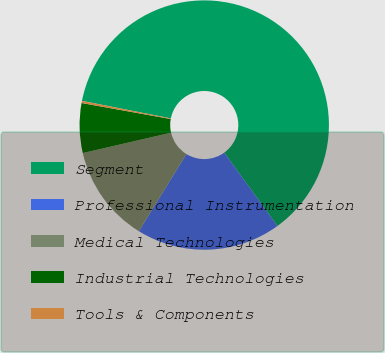<chart> <loc_0><loc_0><loc_500><loc_500><pie_chart><fcel>Segment<fcel>Professional Instrumentation<fcel>Medical Technologies<fcel>Industrial Technologies<fcel>Tools & Components<nl><fcel>61.91%<fcel>18.77%<fcel>12.6%<fcel>6.44%<fcel>0.28%<nl></chart> 